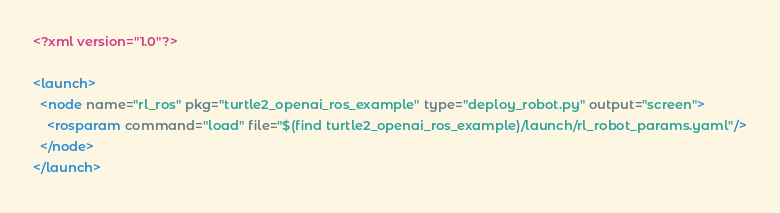Convert code to text. <code><loc_0><loc_0><loc_500><loc_500><_XML_><?xml version="1.0"?>

<launch>
  <node name="rl_ros" pkg="turtle2_openai_ros_example" type="deploy_robot.py" output="screen">
    <rosparam command="load" file="$(find turtle2_openai_ros_example)/launch/rl_robot_params.yaml"/>
  </node>
</launch>
</code> 